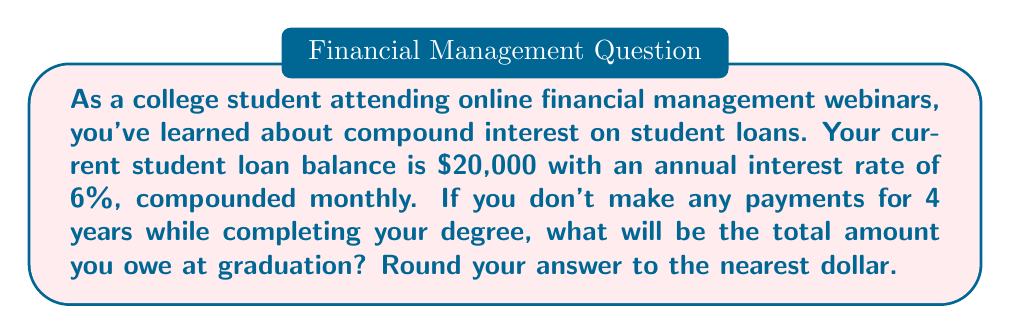Can you solve this math problem? To solve this problem, we'll use the compound interest formula:

$$A = P(1 + \frac{r}{n})^{nt}$$

Where:
$A$ = final amount
$P$ = principal (initial balance)
$r$ = annual interest rate (in decimal form)
$n$ = number of times interest is compounded per year
$t$ = number of years

Given:
$P = \$20,000$
$r = 6\% = 0.06$
$n = 12$ (compounded monthly)
$t = 4$ years

Let's substitute these values into the formula:

$$A = 20000(1 + \frac{0.06}{12})^{12 \cdot 4}$$

$$A = 20000(1 + 0.005)^{48}$$

$$A = 20000(1.005)^{48}$$

Using a calculator or spreadsheet to compute this:

$$A = 20000 \cdot 1.2697954$$

$$A = 25395.91$$

Rounding to the nearest dollar:

$$A \approx \$25,396$$
Answer: $25,396 